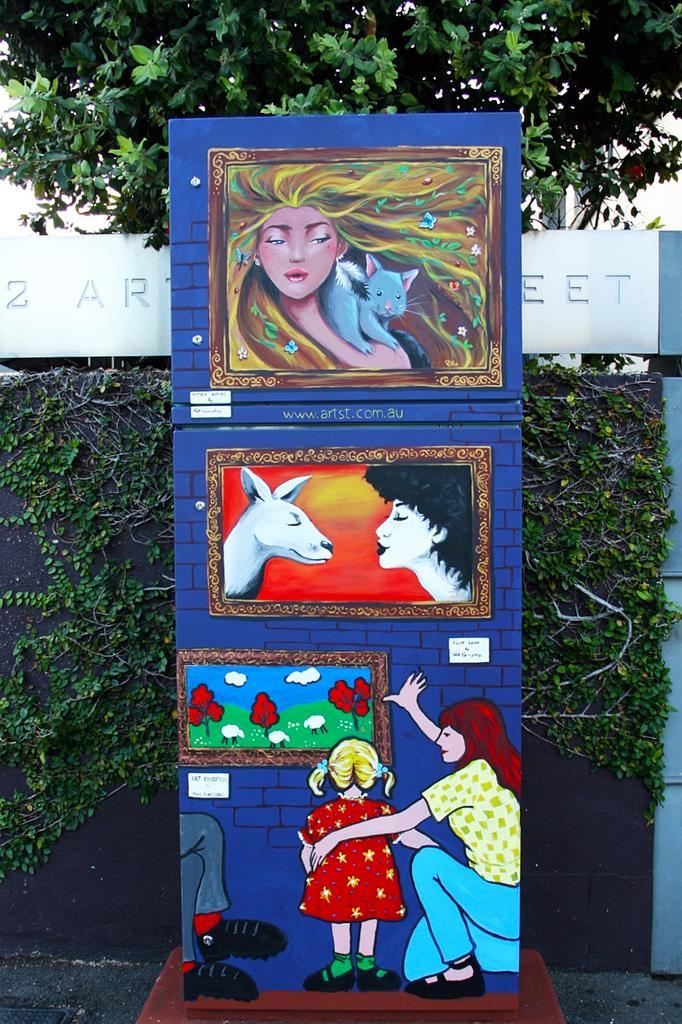Could you give a brief overview of what you see in this image? In the picture we can see blue color board on which we can see the art painting of some images and animals. In the background, we can see the creepers on the wall, we can see a board on which we can see some text and we can see the trees. 